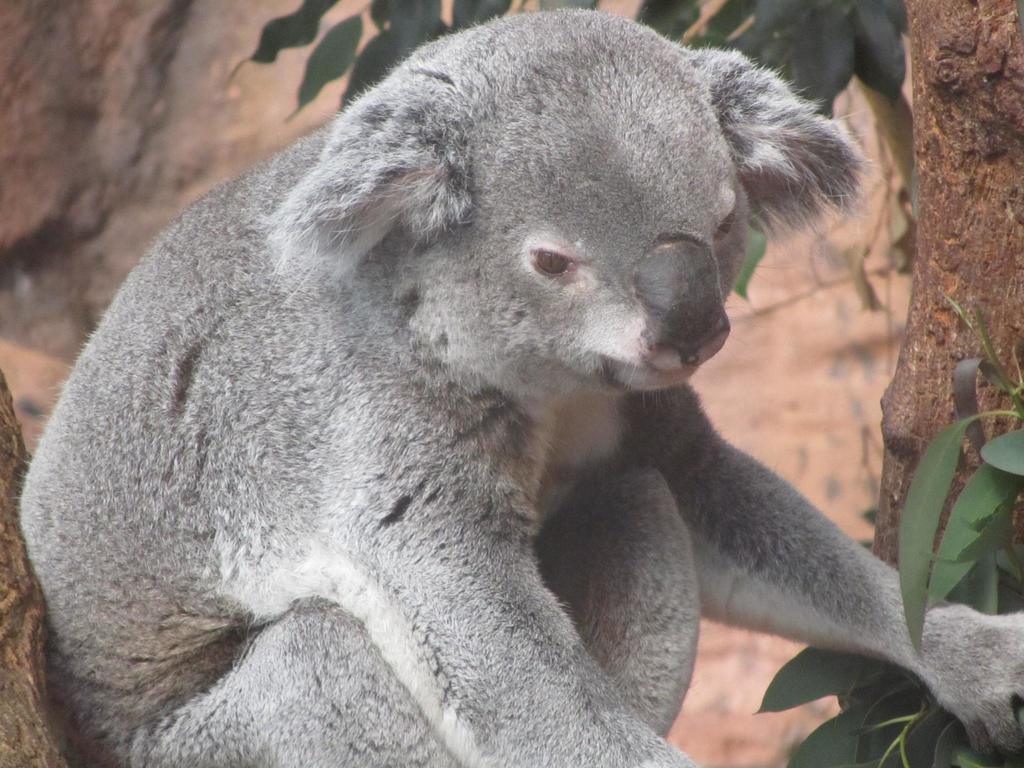What type of animal is in the image? There is a grey color koala in the image. Where is the koala located? The koala is sitting on a tree branch. What can be seen on the tree branch? There are green leaves in the image. How would you describe the background of the image? The background of the image is blurred. What color is the blood on the koala's mind in the image? There is no blood or mention of a mind in the image; it features a grey color koala sitting on a tree branch with green leaves. --- Facts: 1. There is a person holding a camera in the image. 2. The person is standing on a bridge. 3. The bridge is over a river. 4. There are mountains in the background. 5. The sky is visible in the image. Absurd Topics: pizza, dance, car Conversation: What is the person in the image doing? The person in the image is holding a camera. Where is the person standing? The person is standing on a bridge. What is the bridge crossing in the image? The bridge is over a river. What can be seen in the background of the image? There are mountains in the background. What is visible in the sky in the image? The sky is visible in the image. Reasoning: Let's think step by step in order to produce the conversation. We start by identifying the main subject in the image, which is the person holding a camera. Then, we expand the conversation to include the person's location (on a bridge) and the presence of a river, mountains, and the sky. Each question is designed to elicit a specific detail about the image that is known from the provided facts. Absurd Question/Answer: What type of pizza is the person eating while dancing on the car in the image? There is no pizza, dancing, or car present in the image; it features a person holding a camera on a bridge over a river with mountains in the background and the sky visible. 